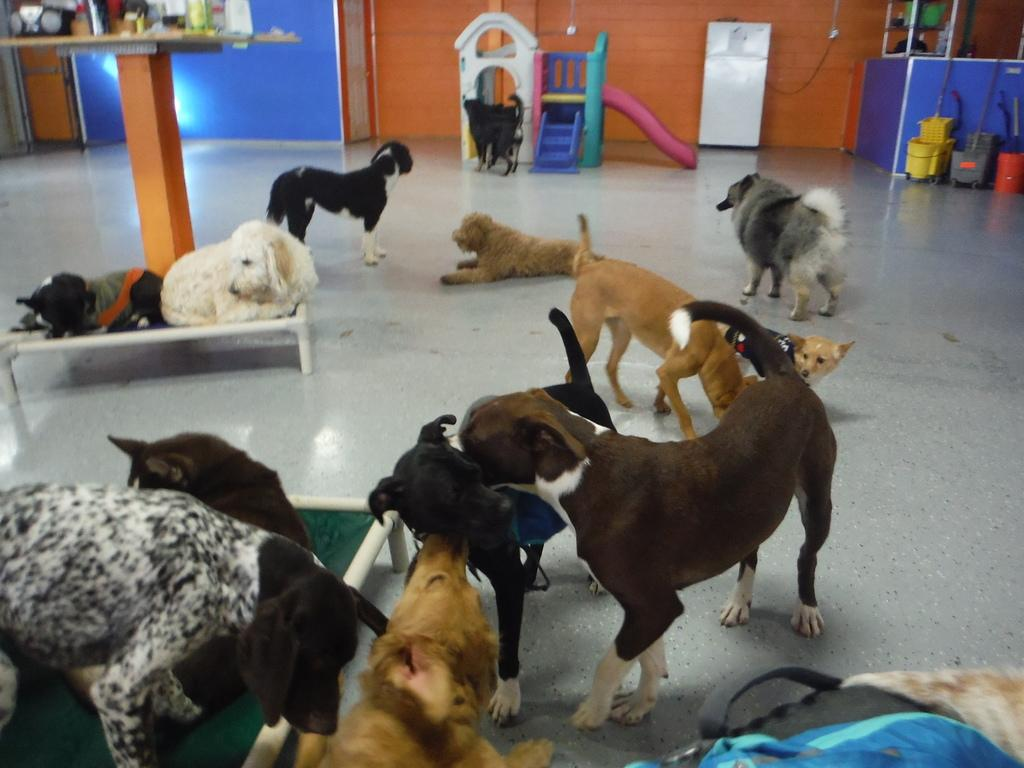What are the dogs doing in the image? There are dogs standing and laying in the image. What is located behind the dogs? There is a table, a slide toy, objects, and a wall behind the dogs. What type of lettuce can be seen growing on the wall behind the dogs? There is no lettuce visible in the image; the wall is behind the dogs, but it does not show any plants or vegetation. 